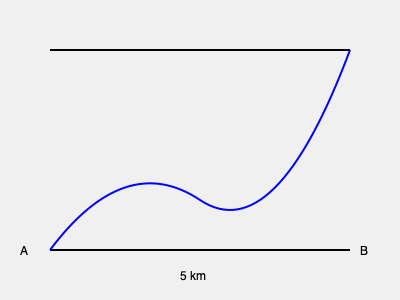A hiker asks about the distance between points A and B on a topographic trail map. The straight-line distance between A and B is 5 km, but the trail follows a winding path as shown. Estimate the actual trail distance between A and B. To estimate the actual trail distance, we can use the following steps:

1. Observe that the straight-line distance between A and B is 5 km.

2. Notice that the trail follows a winding path that is longer than the straight line.

3. Estimate the curve factor:
   - A general rule of thumb for estimating distances on topographic maps is to add 25-50% to the straight-line distance, depending on the terrain.
   - In this case, the trail has moderate curves, so we'll use a 30% increase.

4. Calculate the estimated trail distance:
   $\text{Trail Distance} = \text{Straight-line Distance} \times (1 + \text{Curve Factor})$
   $\text{Trail Distance} = 5 \text{ km} \times (1 + 0.30)$
   $\text{Trail Distance} = 5 \text{ km} \times 1.30$
   $\text{Trail Distance} = 6.5 \text{ km}$

5. Round to a reasonable precision for an estimate:
   $\text{Estimated Trail Distance} \approx 6.5 \text{ km}$
Answer: Approximately 6.5 km 